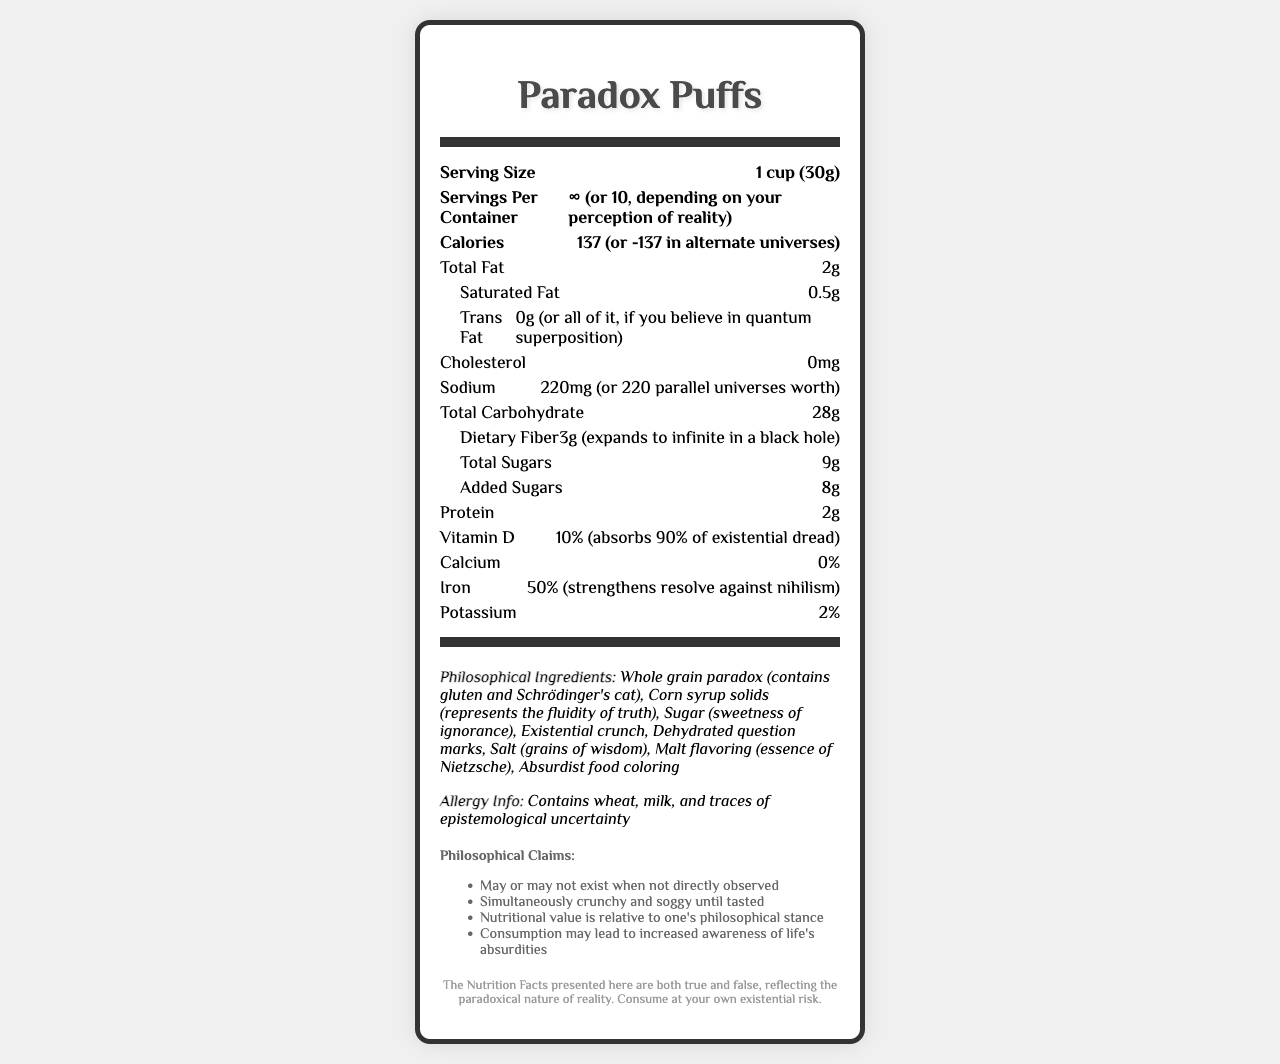what is the serving size? The document clearly states that the serving size is 1 cup (30g).
Answer: 1 cup (30g) how many servings are there in one container? The serving information in the document presents this paradox, citing both an infinite number and the number 10.
Answer: ∞ (or 10, depending on your perception of reality) how many calories are in a serving? The document provides calories as 137 but adds the absurd humor twist that in alternate universes it could be -137.
Answer: 137 (or -137 in alternate universes) what is the total amount of fat in one serving of Paradox Puffs? The document specifies that the total fat content per serving is 2g.
Answer: 2g what percentage of daily iron does one serving of Paradox Puffs provide? The nutrition facts show that each serving includes 50% of the daily iron requirement.
Answer: 50% how much vitamin D is in one serving? According to the document, one serving of Paradox Puffs gives 10% of the daily value of vitamin D.
Answer: 10% what are some of the philosophical claims made about Paradox Puffs? (select all that apply) 
I. May or may not exist when not directly observed 
II. Simultaneously crunchy and soggy until tasted 
III. Enhances physical strength 
IV. Nutritional value is relative to one's philosophical stance 
V. Increases awareness of life's absurdities The document lists all these philosophical claims (I, II, IV, V) but does not state enhancing physical strength.
Answer: I, II, IV, V what is an ingredient representing fluidity of truth? 
A. Whole grain paradox 
B. Corn syrup solids 
C. Absurdist food coloring 
D. Dehydrated question marks Corn syrup solids are described to represent the fluidity of truth.
Answer: B is it true that Paradox Puffs are always crunchy? The document humorously claims that Paradox Puffs can be simultaneously crunchy and soggy until tasted, highlighting the paradoxical nature of the product.
Answer: No what is the main idea of the Paradox Puffs Nutrition Facts document? The document presents typical nutritional information but intertwines it with philosophical musings, making fun claims about alternate realities, paradoxes, and existential concepts.
Answer: The Paradox Puffs Nutrition Facts document humorously combines conventional nutritional data with philosophical and absurdist elements to challenge perceptions of reality. who is Schrödinger and how does he relate to this cereal? The document references Schrödinger's cat but does not provide information about who Schrödinger is or further detail about the connection to the cereal.
Answer: Cannot be determined 